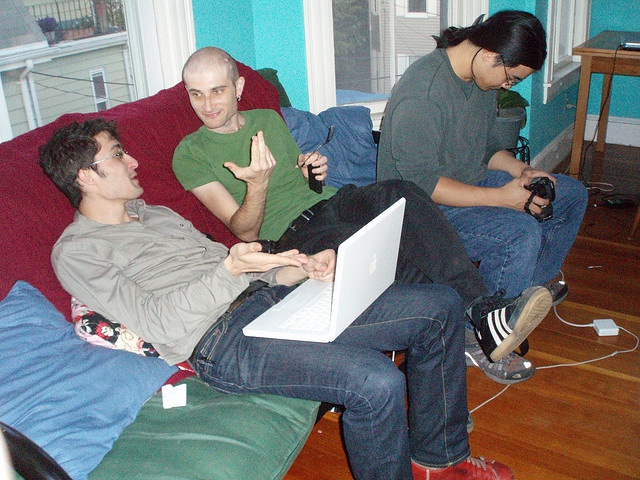Describe the objects in this image and their specific colors. I can see people in gray, darkgray, lightgray, and blue tones, couch in gray, teal, brown, and lightblue tones, people in gray, black, green, and tan tones, people in gray, blue, black, and tan tones, and laptop in gray, white, darkgray, and black tones in this image. 